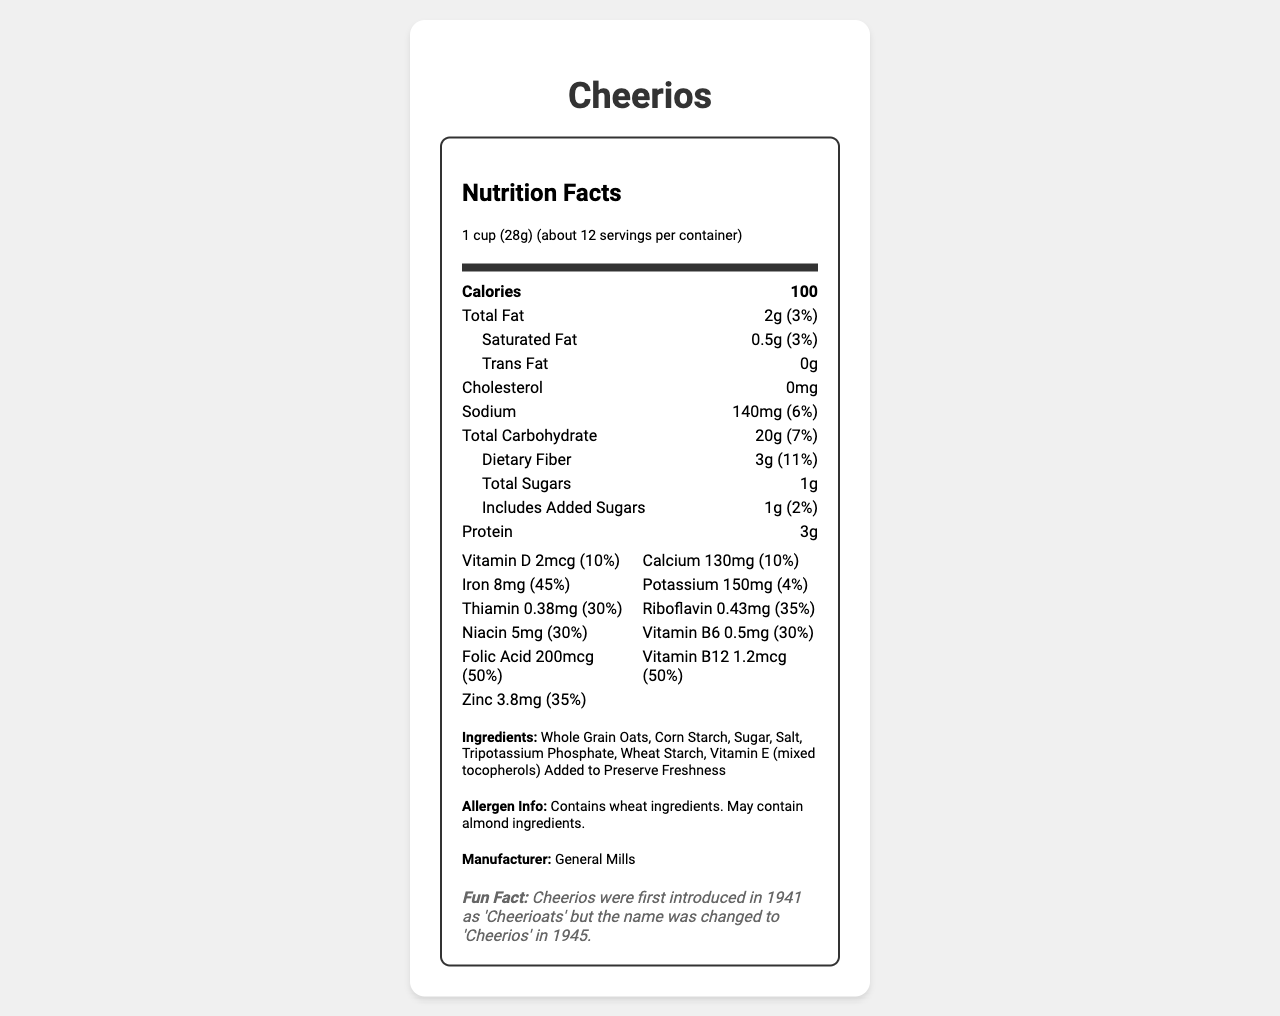what is the serving size for Cheerios? The serving size is stated at the beginning of the nutrition facts section as "1 cup (28g)".
Answer: 1 cup (28g) how many calories are in one serving of Cheerios? The calories per serving are listed in the bolded part of the nutrition facts.
Answer: 100 calories what is the amount of dietary fiber in one serving and its daily value percentage? The dietary fiber amount and its daily value percentage are listed under the total carbohydrate section.
Answer: 3g, 11% which vitamin in Cheerios has the highest daily value percentage? Folic Acid has a daily value percentage of 50%, which is the highest among all the vitamins and minerals listed.
Answer: Folic Acid does Cheerios contain any trans fat? The document states that trans fat is "0g".
Answer: No how much protein is in one serving of Cheerios? The amount of protein per serving is listed directly as 3g.
Answer: 3g what is the amount of sodium and its daily value percentage in one serving of Cheerios? The sodium amount and its daily value percentage are listed in the nutrition facts.
Answer: 140mg, 6% what is the first ingredient listed for Cheerios? The first ingredient listed is "Whole Grain Oats", indicating it's the primary ingredient.
Answer: Whole Grain Oats which company manufactures Cheerios? The manufacturer is listed as "General Mills".
Answer: General Mills which of the following vitamins is NOT listed in the Cheerios nutrition facts: A. Vitamin C B. Vitamin D C. Vitamin B12 D. Vitamin B6 Vitamin C is not listed; the document lists Vitamin D, Vitamin B12, and Vitamin B6.
Answer: A. Vitamin C which of the following allergens might be present in Cheerios: 1. Peanuts 2. Almonds 3. Soy 4. Dairy The allergen info mentions that Cheerios may contain almond ingredients.
Answer: 2. Almonds is it true that Cheerios contain cholesterol? The document states that cholesterol is 0mg.
Answer: No summarize the main information provided by this document This document gives a comprehensive overview of the nutritional content, key ingredients, and allergen details for Cheerios, and it includes both quantitative data and a historical tidbit about the cereal.
Answer: The document provides detailed nutritional information about the popular breakfast cereal, Cheerios. It includes serving size, calories, and the amounts and daily values of various nutrients such as fats, carbohydrates, proteins, vitamins, and minerals. The document also lists ingredients, allergen information, the manufacturer, and a fun historical fact about the product. when did General Mills introduce Cheerios with its current name? The fun fact at the bottom of the document mentions that the name was changed to "Cheerios" in 1945.
Answer: 1945 what are the daily values of Thiamin and Riboflavin in one serving? The document lists daily values of 30% for Thiamin and 35% for Riboflavin within the vitamins section.
Answer: 30% for Thiamin, 35% for Riboflavin what temperature should Cheerios be stored at to maintain freshness? The document does not provide any information about the storage temperature for maintaining freshness of Cheerios.
Answer: Not enough information 